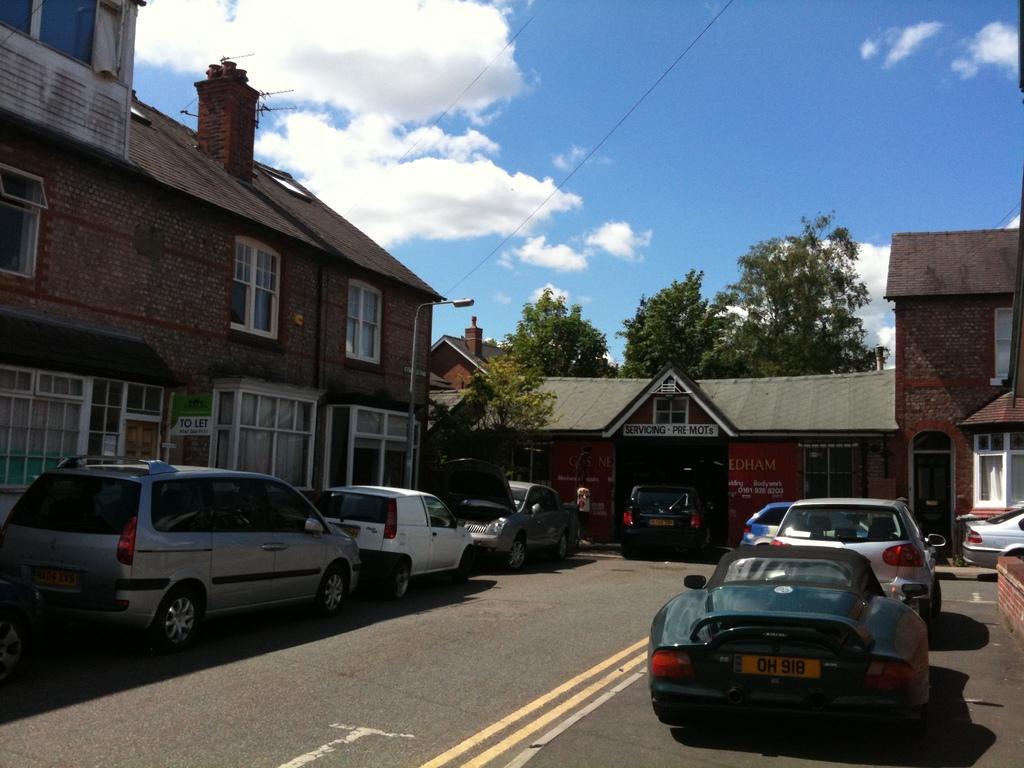Can you describe this image briefly? In this image there are buildings. At the bottom there are cars on the road. In the background there are trees and we can see a pole. At the top there is sky and we can see wires. 